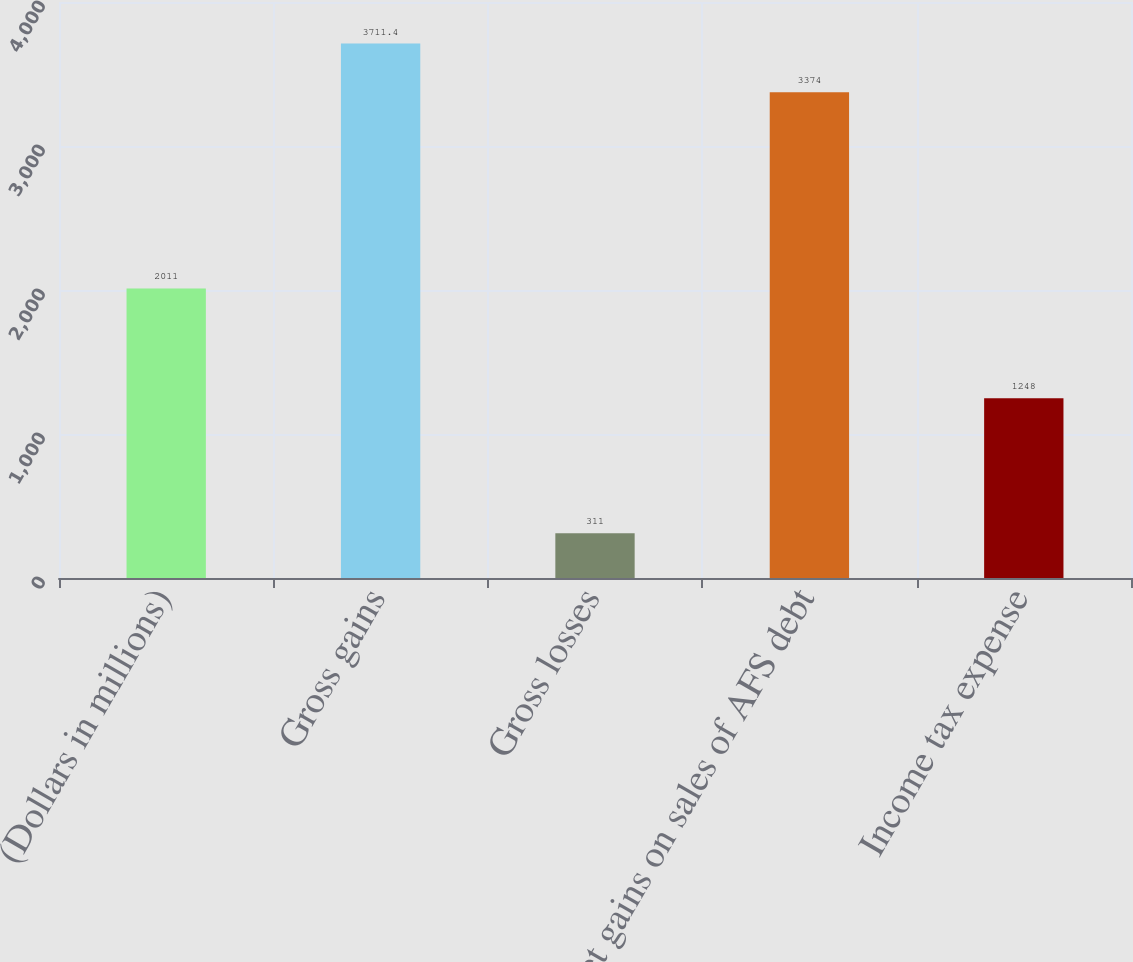<chart> <loc_0><loc_0><loc_500><loc_500><bar_chart><fcel>(Dollars in millions)<fcel>Gross gains<fcel>Gross losses<fcel>Net gains on sales of AFS debt<fcel>Income tax expense<nl><fcel>2011<fcel>3711.4<fcel>311<fcel>3374<fcel>1248<nl></chart> 